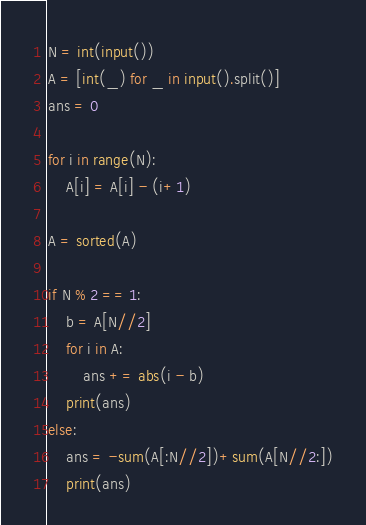Convert code to text. <code><loc_0><loc_0><loc_500><loc_500><_Python_>N = int(input())
A = [int(_) for _ in input().split()]
ans = 0

for i in range(N):
    A[i] = A[i] - (i+1)

A = sorted(A)

if N % 2 == 1:
    b = A[N//2]
    for i in A:
        ans += abs(i - b)
    print(ans)
else:
    ans = -sum(A[:N//2])+sum(A[N//2:])
    print(ans)</code> 